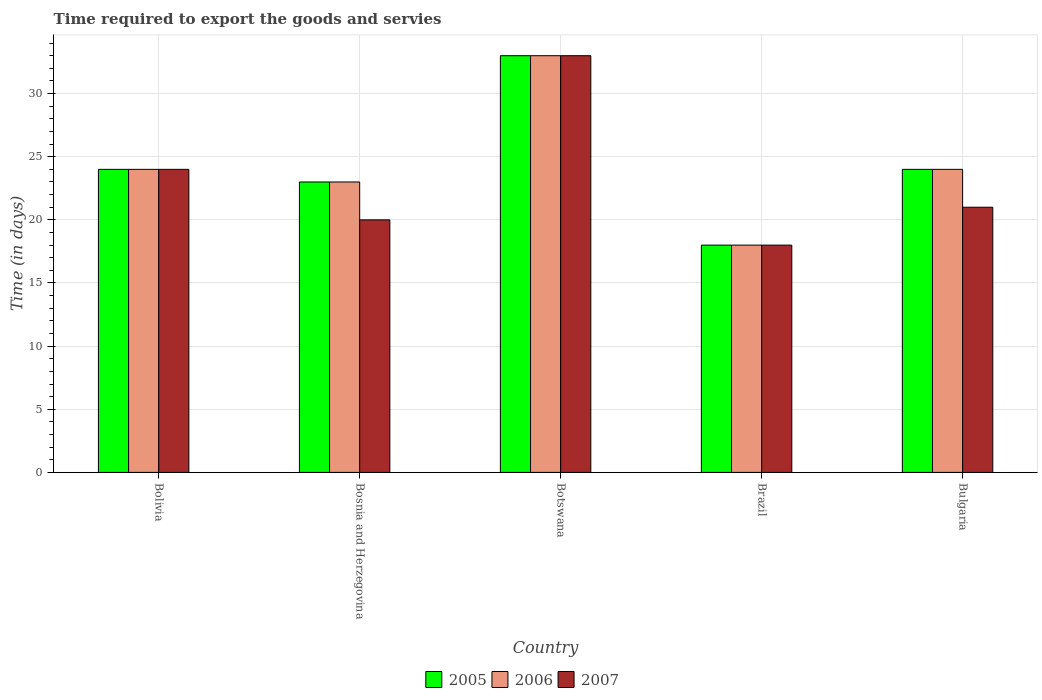How many different coloured bars are there?
Your answer should be compact. 3. Are the number of bars on each tick of the X-axis equal?
Offer a very short reply. Yes. How many bars are there on the 1st tick from the right?
Ensure brevity in your answer.  3. What is the label of the 3rd group of bars from the left?
Ensure brevity in your answer.  Botswana. In how many cases, is the number of bars for a given country not equal to the number of legend labels?
Keep it short and to the point. 0. What is the number of days required to export the goods and services in 2005 in Bosnia and Herzegovina?
Make the answer very short. 23. Across all countries, what is the maximum number of days required to export the goods and services in 2006?
Your answer should be very brief. 33. In which country was the number of days required to export the goods and services in 2007 maximum?
Give a very brief answer. Botswana. What is the total number of days required to export the goods and services in 2007 in the graph?
Your response must be concise. 116. What is the difference between the number of days required to export the goods and services in 2006 in Bulgaria and the number of days required to export the goods and services in 2007 in Brazil?
Provide a short and direct response. 6. What is the average number of days required to export the goods and services in 2005 per country?
Your answer should be very brief. 24.4. What is the difference between the number of days required to export the goods and services of/in 2006 and number of days required to export the goods and services of/in 2005 in Brazil?
Provide a short and direct response. 0. In how many countries, is the number of days required to export the goods and services in 2007 greater than 18 days?
Ensure brevity in your answer.  4. What is the ratio of the number of days required to export the goods and services in 2005 in Botswana to that in Bulgaria?
Ensure brevity in your answer.  1.38. Is the number of days required to export the goods and services in 2007 in Botswana less than that in Bulgaria?
Your answer should be very brief. No. Is the difference between the number of days required to export the goods and services in 2006 in Botswana and Bulgaria greater than the difference between the number of days required to export the goods and services in 2005 in Botswana and Bulgaria?
Provide a short and direct response. No. What is the difference between the highest and the second highest number of days required to export the goods and services in 2007?
Your response must be concise. -9. In how many countries, is the number of days required to export the goods and services in 2006 greater than the average number of days required to export the goods and services in 2006 taken over all countries?
Keep it short and to the point. 1. Is the sum of the number of days required to export the goods and services in 2005 in Bolivia and Brazil greater than the maximum number of days required to export the goods and services in 2006 across all countries?
Offer a terse response. Yes. What does the 2nd bar from the right in Bosnia and Herzegovina represents?
Provide a short and direct response. 2006. Is it the case that in every country, the sum of the number of days required to export the goods and services in 2005 and number of days required to export the goods and services in 2006 is greater than the number of days required to export the goods and services in 2007?
Your response must be concise. Yes. Are all the bars in the graph horizontal?
Your answer should be compact. No. What is the difference between two consecutive major ticks on the Y-axis?
Give a very brief answer. 5. Are the values on the major ticks of Y-axis written in scientific E-notation?
Offer a very short reply. No. Does the graph contain grids?
Make the answer very short. Yes. Where does the legend appear in the graph?
Offer a very short reply. Bottom center. What is the title of the graph?
Ensure brevity in your answer.  Time required to export the goods and servies. What is the label or title of the X-axis?
Provide a short and direct response. Country. What is the label or title of the Y-axis?
Ensure brevity in your answer.  Time (in days). What is the Time (in days) of 2007 in Bolivia?
Provide a short and direct response. 24. What is the Time (in days) in 2007 in Bosnia and Herzegovina?
Your answer should be compact. 20. What is the Time (in days) of 2006 in Botswana?
Provide a short and direct response. 33. What is the Time (in days) in 2007 in Brazil?
Make the answer very short. 18. What is the Time (in days) in 2005 in Bulgaria?
Give a very brief answer. 24. What is the Time (in days) in 2006 in Bulgaria?
Keep it short and to the point. 24. Across all countries, what is the maximum Time (in days) of 2007?
Ensure brevity in your answer.  33. Across all countries, what is the minimum Time (in days) in 2005?
Your answer should be very brief. 18. What is the total Time (in days) of 2005 in the graph?
Keep it short and to the point. 122. What is the total Time (in days) of 2006 in the graph?
Offer a terse response. 122. What is the total Time (in days) of 2007 in the graph?
Give a very brief answer. 116. What is the difference between the Time (in days) in 2006 in Bolivia and that in Bosnia and Herzegovina?
Ensure brevity in your answer.  1. What is the difference between the Time (in days) in 2007 in Bolivia and that in Bosnia and Herzegovina?
Your answer should be very brief. 4. What is the difference between the Time (in days) in 2007 in Bolivia and that in Botswana?
Offer a very short reply. -9. What is the difference between the Time (in days) in 2007 in Bolivia and that in Brazil?
Your answer should be very brief. 6. What is the difference between the Time (in days) in 2006 in Bolivia and that in Bulgaria?
Provide a short and direct response. 0. What is the difference between the Time (in days) in 2007 in Bosnia and Herzegovina and that in Botswana?
Ensure brevity in your answer.  -13. What is the difference between the Time (in days) in 2005 in Bosnia and Herzegovina and that in Brazil?
Keep it short and to the point. 5. What is the difference between the Time (in days) in 2006 in Bosnia and Herzegovina and that in Brazil?
Provide a short and direct response. 5. What is the difference between the Time (in days) in 2007 in Bosnia and Herzegovina and that in Brazil?
Provide a short and direct response. 2. What is the difference between the Time (in days) of 2005 in Bosnia and Herzegovina and that in Bulgaria?
Offer a terse response. -1. What is the difference between the Time (in days) in 2006 in Bosnia and Herzegovina and that in Bulgaria?
Your answer should be very brief. -1. What is the difference between the Time (in days) of 2005 in Botswana and that in Brazil?
Keep it short and to the point. 15. What is the difference between the Time (in days) in 2006 in Botswana and that in Brazil?
Make the answer very short. 15. What is the difference between the Time (in days) in 2007 in Botswana and that in Brazil?
Make the answer very short. 15. What is the difference between the Time (in days) in 2006 in Botswana and that in Bulgaria?
Give a very brief answer. 9. What is the difference between the Time (in days) in 2007 in Botswana and that in Bulgaria?
Offer a very short reply. 12. What is the difference between the Time (in days) of 2005 in Brazil and that in Bulgaria?
Offer a very short reply. -6. What is the difference between the Time (in days) of 2005 in Bolivia and the Time (in days) of 2006 in Bosnia and Herzegovina?
Offer a very short reply. 1. What is the difference between the Time (in days) in 2005 in Bolivia and the Time (in days) in 2007 in Bosnia and Herzegovina?
Provide a succinct answer. 4. What is the difference between the Time (in days) of 2005 in Bolivia and the Time (in days) of 2006 in Botswana?
Provide a short and direct response. -9. What is the difference between the Time (in days) in 2005 in Bolivia and the Time (in days) in 2007 in Botswana?
Keep it short and to the point. -9. What is the difference between the Time (in days) of 2005 in Bolivia and the Time (in days) of 2006 in Brazil?
Provide a short and direct response. 6. What is the difference between the Time (in days) of 2006 in Bolivia and the Time (in days) of 2007 in Brazil?
Offer a terse response. 6. What is the difference between the Time (in days) of 2005 in Bosnia and Herzegovina and the Time (in days) of 2007 in Botswana?
Your answer should be very brief. -10. What is the difference between the Time (in days) of 2006 in Bosnia and Herzegovina and the Time (in days) of 2007 in Botswana?
Your answer should be compact. -10. What is the difference between the Time (in days) of 2005 in Bosnia and Herzegovina and the Time (in days) of 2006 in Brazil?
Offer a very short reply. 5. What is the difference between the Time (in days) in 2005 in Bosnia and Herzegovina and the Time (in days) in 2007 in Brazil?
Provide a short and direct response. 5. What is the difference between the Time (in days) of 2006 in Bosnia and Herzegovina and the Time (in days) of 2007 in Brazil?
Provide a short and direct response. 5. What is the difference between the Time (in days) of 2005 in Bosnia and Herzegovina and the Time (in days) of 2006 in Bulgaria?
Make the answer very short. -1. What is the difference between the Time (in days) of 2006 in Bosnia and Herzegovina and the Time (in days) of 2007 in Bulgaria?
Make the answer very short. 2. What is the difference between the Time (in days) in 2006 in Botswana and the Time (in days) in 2007 in Brazil?
Provide a short and direct response. 15. What is the difference between the Time (in days) of 2005 in Botswana and the Time (in days) of 2006 in Bulgaria?
Your answer should be compact. 9. What is the difference between the Time (in days) in 2006 in Botswana and the Time (in days) in 2007 in Bulgaria?
Provide a succinct answer. 12. What is the difference between the Time (in days) in 2005 in Brazil and the Time (in days) in 2007 in Bulgaria?
Your response must be concise. -3. What is the average Time (in days) in 2005 per country?
Keep it short and to the point. 24.4. What is the average Time (in days) of 2006 per country?
Your response must be concise. 24.4. What is the average Time (in days) of 2007 per country?
Ensure brevity in your answer.  23.2. What is the difference between the Time (in days) in 2005 and Time (in days) in 2006 in Bolivia?
Your answer should be very brief. 0. What is the difference between the Time (in days) in 2005 and Time (in days) in 2006 in Bosnia and Herzegovina?
Your answer should be compact. 0. What is the difference between the Time (in days) in 2005 and Time (in days) in 2007 in Bosnia and Herzegovina?
Offer a very short reply. 3. What is the difference between the Time (in days) in 2006 and Time (in days) in 2007 in Botswana?
Ensure brevity in your answer.  0. What is the difference between the Time (in days) of 2005 and Time (in days) of 2006 in Brazil?
Give a very brief answer. 0. What is the difference between the Time (in days) in 2006 and Time (in days) in 2007 in Brazil?
Provide a short and direct response. 0. What is the difference between the Time (in days) in 2005 and Time (in days) in 2007 in Bulgaria?
Offer a very short reply. 3. What is the difference between the Time (in days) in 2006 and Time (in days) in 2007 in Bulgaria?
Keep it short and to the point. 3. What is the ratio of the Time (in days) in 2005 in Bolivia to that in Bosnia and Herzegovina?
Provide a short and direct response. 1.04. What is the ratio of the Time (in days) of 2006 in Bolivia to that in Bosnia and Herzegovina?
Your answer should be very brief. 1.04. What is the ratio of the Time (in days) in 2005 in Bolivia to that in Botswana?
Offer a very short reply. 0.73. What is the ratio of the Time (in days) of 2006 in Bolivia to that in Botswana?
Your answer should be compact. 0.73. What is the ratio of the Time (in days) of 2007 in Bolivia to that in Botswana?
Provide a succinct answer. 0.73. What is the ratio of the Time (in days) in 2005 in Bolivia to that in Brazil?
Give a very brief answer. 1.33. What is the ratio of the Time (in days) in 2007 in Bolivia to that in Brazil?
Keep it short and to the point. 1.33. What is the ratio of the Time (in days) in 2005 in Bolivia to that in Bulgaria?
Provide a succinct answer. 1. What is the ratio of the Time (in days) in 2007 in Bolivia to that in Bulgaria?
Ensure brevity in your answer.  1.14. What is the ratio of the Time (in days) in 2005 in Bosnia and Herzegovina to that in Botswana?
Ensure brevity in your answer.  0.7. What is the ratio of the Time (in days) of 2006 in Bosnia and Herzegovina to that in Botswana?
Provide a short and direct response. 0.7. What is the ratio of the Time (in days) in 2007 in Bosnia and Herzegovina to that in Botswana?
Your response must be concise. 0.61. What is the ratio of the Time (in days) of 2005 in Bosnia and Herzegovina to that in Brazil?
Your response must be concise. 1.28. What is the ratio of the Time (in days) in 2006 in Bosnia and Herzegovina to that in Brazil?
Keep it short and to the point. 1.28. What is the ratio of the Time (in days) in 2007 in Bosnia and Herzegovina to that in Brazil?
Your answer should be compact. 1.11. What is the ratio of the Time (in days) of 2005 in Bosnia and Herzegovina to that in Bulgaria?
Your response must be concise. 0.96. What is the ratio of the Time (in days) in 2006 in Bosnia and Herzegovina to that in Bulgaria?
Provide a succinct answer. 0.96. What is the ratio of the Time (in days) in 2005 in Botswana to that in Brazil?
Keep it short and to the point. 1.83. What is the ratio of the Time (in days) of 2006 in Botswana to that in Brazil?
Give a very brief answer. 1.83. What is the ratio of the Time (in days) of 2007 in Botswana to that in Brazil?
Provide a short and direct response. 1.83. What is the ratio of the Time (in days) of 2005 in Botswana to that in Bulgaria?
Offer a terse response. 1.38. What is the ratio of the Time (in days) of 2006 in Botswana to that in Bulgaria?
Provide a succinct answer. 1.38. What is the ratio of the Time (in days) in 2007 in Botswana to that in Bulgaria?
Keep it short and to the point. 1.57. What is the ratio of the Time (in days) in 2005 in Brazil to that in Bulgaria?
Provide a succinct answer. 0.75. What is the ratio of the Time (in days) of 2006 in Brazil to that in Bulgaria?
Your answer should be very brief. 0.75. What is the difference between the highest and the second highest Time (in days) in 2005?
Your response must be concise. 9. What is the difference between the highest and the second highest Time (in days) in 2007?
Provide a succinct answer. 9. What is the difference between the highest and the lowest Time (in days) of 2005?
Your response must be concise. 15. 